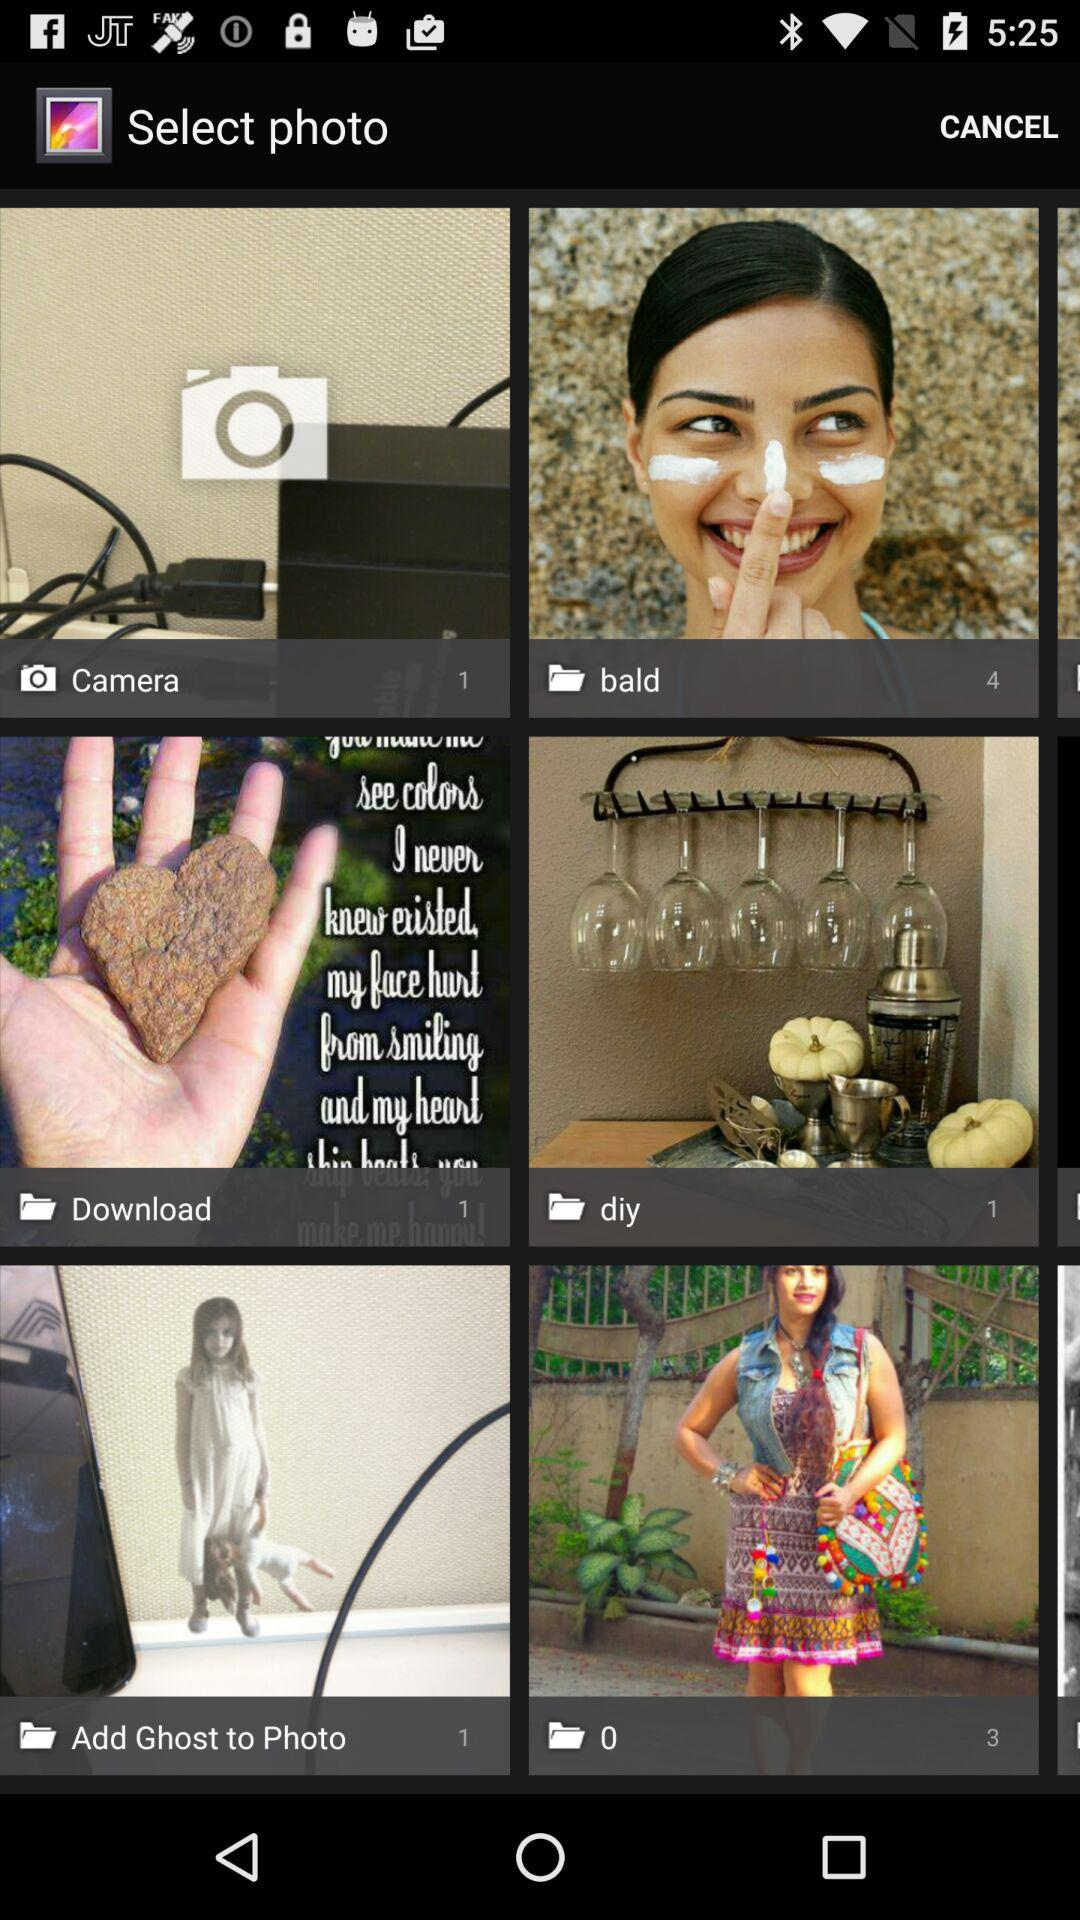What is the number of images in the "diy" folder? The number of images in the "diy" folder is 1. 